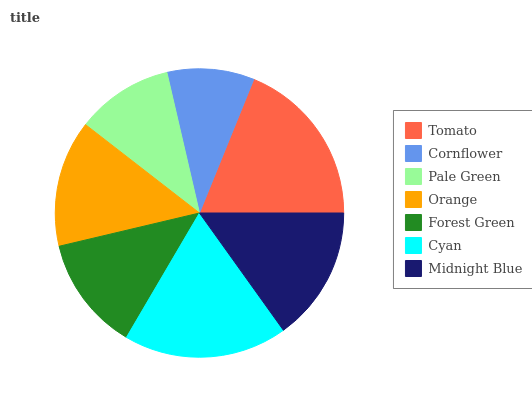Is Cornflower the minimum?
Answer yes or no. Yes. Is Tomato the maximum?
Answer yes or no. Yes. Is Pale Green the minimum?
Answer yes or no. No. Is Pale Green the maximum?
Answer yes or no. No. Is Pale Green greater than Cornflower?
Answer yes or no. Yes. Is Cornflower less than Pale Green?
Answer yes or no. Yes. Is Cornflower greater than Pale Green?
Answer yes or no. No. Is Pale Green less than Cornflower?
Answer yes or no. No. Is Orange the high median?
Answer yes or no. Yes. Is Orange the low median?
Answer yes or no. Yes. Is Forest Green the high median?
Answer yes or no. No. Is Cyan the low median?
Answer yes or no. No. 